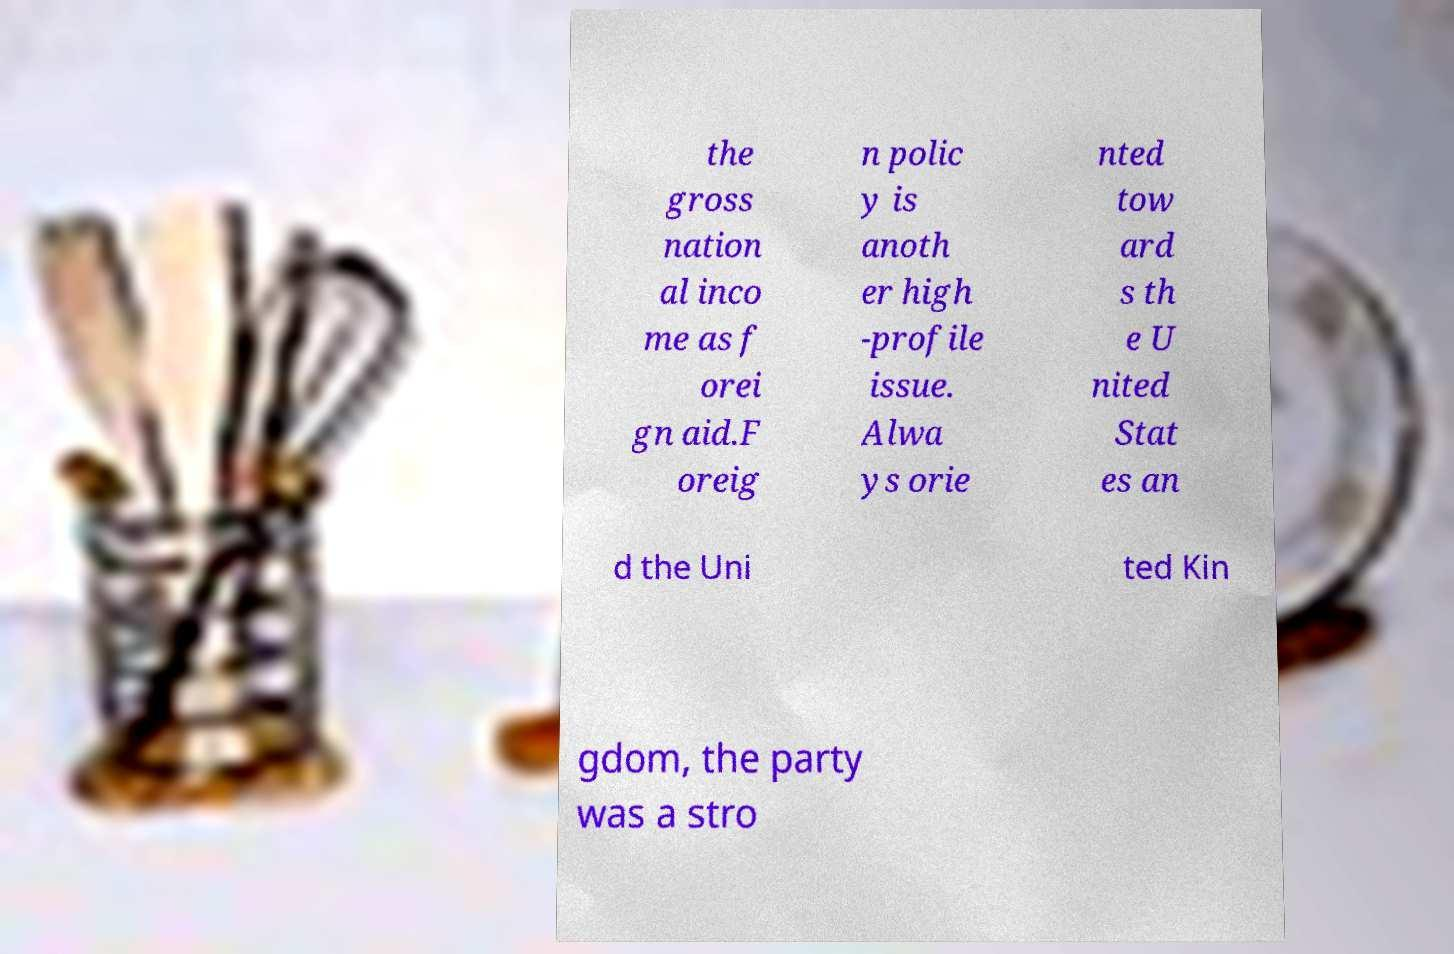What messages or text are displayed in this image? I need them in a readable, typed format. the gross nation al inco me as f orei gn aid.F oreig n polic y is anoth er high -profile issue. Alwa ys orie nted tow ard s th e U nited Stat es an d the Uni ted Kin gdom, the party was a stro 